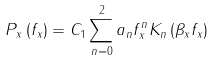Convert formula to latex. <formula><loc_0><loc_0><loc_500><loc_500>P _ { x } \left ( f _ { x } \right ) = C _ { 1 } \sum _ { n = 0 } ^ { 2 } a _ { n } f _ { x } ^ { n } K _ { n } \left ( \beta _ { x } f _ { x } \right )</formula> 